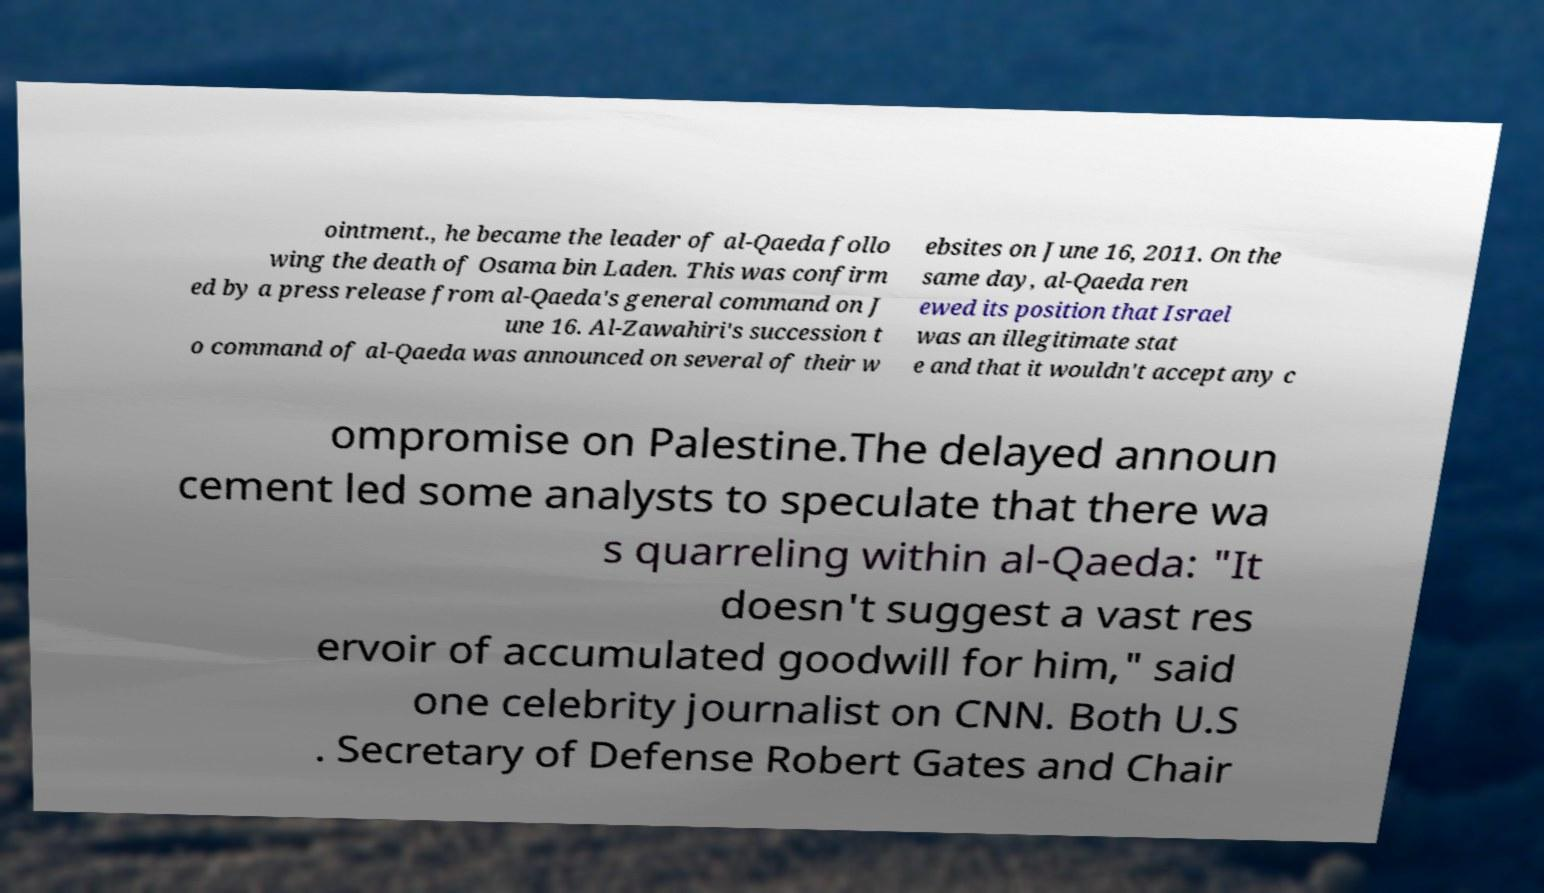What messages or text are displayed in this image? I need them in a readable, typed format. ointment., he became the leader of al-Qaeda follo wing the death of Osama bin Laden. This was confirm ed by a press release from al-Qaeda's general command on J une 16. Al-Zawahiri's succession t o command of al-Qaeda was announced on several of their w ebsites on June 16, 2011. On the same day, al-Qaeda ren ewed its position that Israel was an illegitimate stat e and that it wouldn't accept any c ompromise on Palestine.The delayed announ cement led some analysts to speculate that there wa s quarreling within al-Qaeda: "It doesn't suggest a vast res ervoir of accumulated goodwill for him," said one celebrity journalist on CNN. Both U.S . Secretary of Defense Robert Gates and Chair 